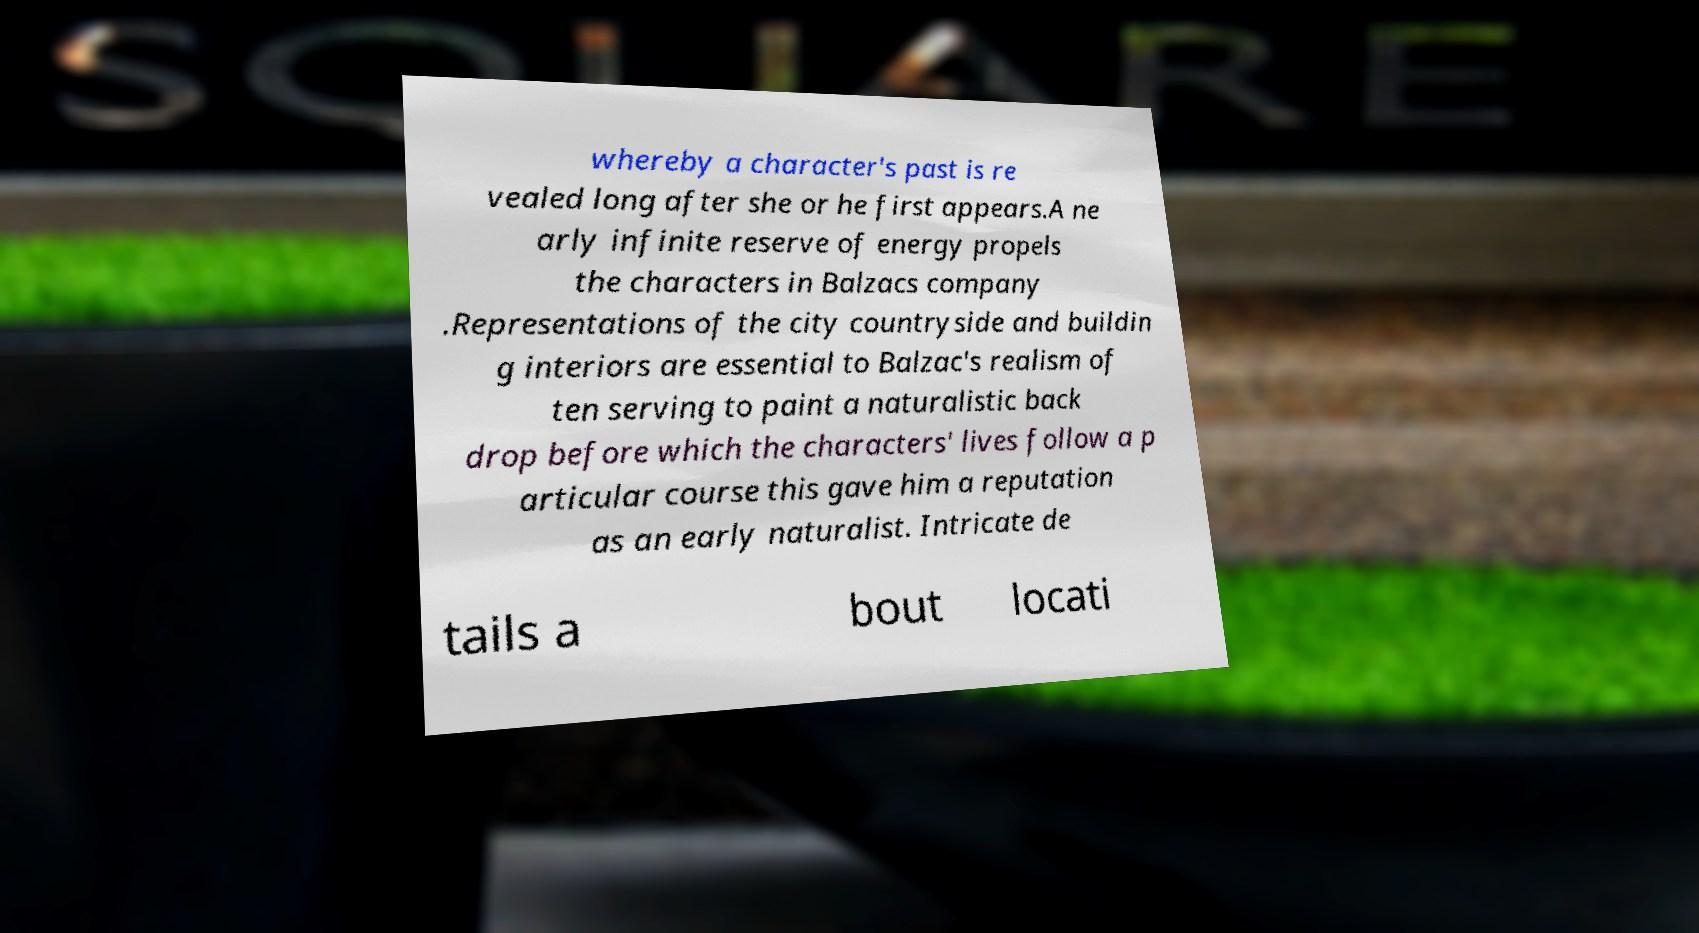Could you assist in decoding the text presented in this image and type it out clearly? whereby a character's past is re vealed long after she or he first appears.A ne arly infinite reserve of energy propels the characters in Balzacs company .Representations of the city countryside and buildin g interiors are essential to Balzac's realism of ten serving to paint a naturalistic back drop before which the characters' lives follow a p articular course this gave him a reputation as an early naturalist. Intricate de tails a bout locati 